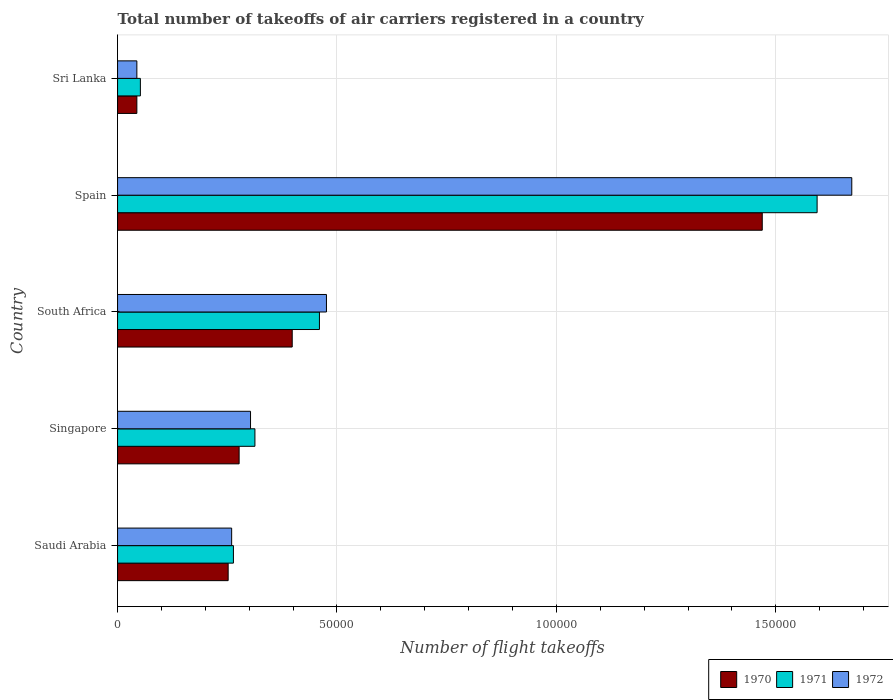How many groups of bars are there?
Offer a very short reply. 5. Are the number of bars per tick equal to the number of legend labels?
Offer a very short reply. Yes. What is the label of the 5th group of bars from the top?
Provide a short and direct response. Saudi Arabia. What is the total number of flight takeoffs in 1972 in Spain?
Your answer should be compact. 1.67e+05. Across all countries, what is the maximum total number of flight takeoffs in 1970?
Provide a succinct answer. 1.47e+05. Across all countries, what is the minimum total number of flight takeoffs in 1970?
Provide a succinct answer. 4400. In which country was the total number of flight takeoffs in 1972 maximum?
Provide a short and direct response. Spain. In which country was the total number of flight takeoffs in 1972 minimum?
Provide a short and direct response. Sri Lanka. What is the total total number of flight takeoffs in 1970 in the graph?
Offer a terse response. 2.44e+05. What is the difference between the total number of flight takeoffs in 1970 in Saudi Arabia and that in Sri Lanka?
Offer a terse response. 2.08e+04. What is the difference between the total number of flight takeoffs in 1971 in South Africa and the total number of flight takeoffs in 1972 in Singapore?
Offer a very short reply. 1.57e+04. What is the average total number of flight takeoffs in 1972 per country?
Ensure brevity in your answer.  5.51e+04. What is the difference between the total number of flight takeoffs in 1972 and total number of flight takeoffs in 1970 in Singapore?
Make the answer very short. 2600. In how many countries, is the total number of flight takeoffs in 1971 greater than 10000 ?
Ensure brevity in your answer.  4. What is the ratio of the total number of flight takeoffs in 1970 in South Africa to that in Spain?
Keep it short and to the point. 0.27. What is the difference between the highest and the second highest total number of flight takeoffs in 1971?
Make the answer very short. 1.13e+05. What is the difference between the highest and the lowest total number of flight takeoffs in 1970?
Provide a succinct answer. 1.42e+05. Is the sum of the total number of flight takeoffs in 1970 in Spain and Sri Lanka greater than the maximum total number of flight takeoffs in 1971 across all countries?
Provide a short and direct response. No. What does the 2nd bar from the bottom in Spain represents?
Offer a very short reply. 1971. How many countries are there in the graph?
Make the answer very short. 5. What is the difference between two consecutive major ticks on the X-axis?
Ensure brevity in your answer.  5.00e+04. Are the values on the major ticks of X-axis written in scientific E-notation?
Your answer should be compact. No. Where does the legend appear in the graph?
Offer a terse response. Bottom right. How many legend labels are there?
Give a very brief answer. 3. What is the title of the graph?
Provide a succinct answer. Total number of takeoffs of air carriers registered in a country. What is the label or title of the X-axis?
Ensure brevity in your answer.  Number of flight takeoffs. What is the label or title of the Y-axis?
Provide a succinct answer. Country. What is the Number of flight takeoffs in 1970 in Saudi Arabia?
Provide a succinct answer. 2.52e+04. What is the Number of flight takeoffs in 1971 in Saudi Arabia?
Offer a very short reply. 2.64e+04. What is the Number of flight takeoffs of 1972 in Saudi Arabia?
Provide a succinct answer. 2.60e+04. What is the Number of flight takeoffs of 1970 in Singapore?
Ensure brevity in your answer.  2.77e+04. What is the Number of flight takeoffs in 1971 in Singapore?
Provide a short and direct response. 3.13e+04. What is the Number of flight takeoffs in 1972 in Singapore?
Your answer should be very brief. 3.03e+04. What is the Number of flight takeoffs of 1970 in South Africa?
Offer a terse response. 3.98e+04. What is the Number of flight takeoffs in 1971 in South Africa?
Ensure brevity in your answer.  4.60e+04. What is the Number of flight takeoffs of 1972 in South Africa?
Your response must be concise. 4.76e+04. What is the Number of flight takeoffs of 1970 in Spain?
Your answer should be compact. 1.47e+05. What is the Number of flight takeoffs in 1971 in Spain?
Your answer should be compact. 1.59e+05. What is the Number of flight takeoffs in 1972 in Spain?
Your answer should be very brief. 1.67e+05. What is the Number of flight takeoffs in 1970 in Sri Lanka?
Offer a very short reply. 4400. What is the Number of flight takeoffs of 1971 in Sri Lanka?
Provide a succinct answer. 5200. What is the Number of flight takeoffs of 1972 in Sri Lanka?
Provide a succinct answer. 4400. Across all countries, what is the maximum Number of flight takeoffs in 1970?
Your answer should be compact. 1.47e+05. Across all countries, what is the maximum Number of flight takeoffs of 1971?
Provide a succinct answer. 1.59e+05. Across all countries, what is the maximum Number of flight takeoffs in 1972?
Offer a very short reply. 1.67e+05. Across all countries, what is the minimum Number of flight takeoffs in 1970?
Ensure brevity in your answer.  4400. Across all countries, what is the minimum Number of flight takeoffs of 1971?
Keep it short and to the point. 5200. Across all countries, what is the minimum Number of flight takeoffs of 1972?
Your answer should be very brief. 4400. What is the total Number of flight takeoffs of 1970 in the graph?
Ensure brevity in your answer.  2.44e+05. What is the total Number of flight takeoffs in 1971 in the graph?
Provide a succinct answer. 2.68e+05. What is the total Number of flight takeoffs of 1972 in the graph?
Offer a terse response. 2.76e+05. What is the difference between the Number of flight takeoffs in 1970 in Saudi Arabia and that in Singapore?
Ensure brevity in your answer.  -2500. What is the difference between the Number of flight takeoffs in 1971 in Saudi Arabia and that in Singapore?
Make the answer very short. -4900. What is the difference between the Number of flight takeoffs of 1972 in Saudi Arabia and that in Singapore?
Offer a very short reply. -4300. What is the difference between the Number of flight takeoffs in 1970 in Saudi Arabia and that in South Africa?
Give a very brief answer. -1.46e+04. What is the difference between the Number of flight takeoffs in 1971 in Saudi Arabia and that in South Africa?
Your response must be concise. -1.96e+04. What is the difference between the Number of flight takeoffs in 1972 in Saudi Arabia and that in South Africa?
Provide a succinct answer. -2.16e+04. What is the difference between the Number of flight takeoffs in 1970 in Saudi Arabia and that in Spain?
Offer a very short reply. -1.22e+05. What is the difference between the Number of flight takeoffs of 1971 in Saudi Arabia and that in Spain?
Your response must be concise. -1.33e+05. What is the difference between the Number of flight takeoffs in 1972 in Saudi Arabia and that in Spain?
Keep it short and to the point. -1.41e+05. What is the difference between the Number of flight takeoffs in 1970 in Saudi Arabia and that in Sri Lanka?
Your answer should be compact. 2.08e+04. What is the difference between the Number of flight takeoffs in 1971 in Saudi Arabia and that in Sri Lanka?
Offer a terse response. 2.12e+04. What is the difference between the Number of flight takeoffs in 1972 in Saudi Arabia and that in Sri Lanka?
Your answer should be very brief. 2.16e+04. What is the difference between the Number of flight takeoffs of 1970 in Singapore and that in South Africa?
Give a very brief answer. -1.21e+04. What is the difference between the Number of flight takeoffs of 1971 in Singapore and that in South Africa?
Make the answer very short. -1.47e+04. What is the difference between the Number of flight takeoffs of 1972 in Singapore and that in South Africa?
Give a very brief answer. -1.73e+04. What is the difference between the Number of flight takeoffs in 1970 in Singapore and that in Spain?
Give a very brief answer. -1.19e+05. What is the difference between the Number of flight takeoffs in 1971 in Singapore and that in Spain?
Your answer should be very brief. -1.28e+05. What is the difference between the Number of flight takeoffs of 1972 in Singapore and that in Spain?
Make the answer very short. -1.37e+05. What is the difference between the Number of flight takeoffs of 1970 in Singapore and that in Sri Lanka?
Make the answer very short. 2.33e+04. What is the difference between the Number of flight takeoffs of 1971 in Singapore and that in Sri Lanka?
Your answer should be compact. 2.61e+04. What is the difference between the Number of flight takeoffs in 1972 in Singapore and that in Sri Lanka?
Ensure brevity in your answer.  2.59e+04. What is the difference between the Number of flight takeoffs in 1970 in South Africa and that in Spain?
Keep it short and to the point. -1.07e+05. What is the difference between the Number of flight takeoffs of 1971 in South Africa and that in Spain?
Offer a terse response. -1.13e+05. What is the difference between the Number of flight takeoffs in 1972 in South Africa and that in Spain?
Offer a terse response. -1.20e+05. What is the difference between the Number of flight takeoffs in 1970 in South Africa and that in Sri Lanka?
Your answer should be compact. 3.54e+04. What is the difference between the Number of flight takeoffs in 1971 in South Africa and that in Sri Lanka?
Keep it short and to the point. 4.08e+04. What is the difference between the Number of flight takeoffs of 1972 in South Africa and that in Sri Lanka?
Your response must be concise. 4.32e+04. What is the difference between the Number of flight takeoffs of 1970 in Spain and that in Sri Lanka?
Provide a short and direct response. 1.42e+05. What is the difference between the Number of flight takeoffs in 1971 in Spain and that in Sri Lanka?
Keep it short and to the point. 1.54e+05. What is the difference between the Number of flight takeoffs of 1972 in Spain and that in Sri Lanka?
Offer a very short reply. 1.63e+05. What is the difference between the Number of flight takeoffs in 1970 in Saudi Arabia and the Number of flight takeoffs in 1971 in Singapore?
Offer a terse response. -6100. What is the difference between the Number of flight takeoffs in 1970 in Saudi Arabia and the Number of flight takeoffs in 1972 in Singapore?
Your answer should be very brief. -5100. What is the difference between the Number of flight takeoffs in 1971 in Saudi Arabia and the Number of flight takeoffs in 1972 in Singapore?
Make the answer very short. -3900. What is the difference between the Number of flight takeoffs of 1970 in Saudi Arabia and the Number of flight takeoffs of 1971 in South Africa?
Offer a very short reply. -2.08e+04. What is the difference between the Number of flight takeoffs of 1970 in Saudi Arabia and the Number of flight takeoffs of 1972 in South Africa?
Your response must be concise. -2.24e+04. What is the difference between the Number of flight takeoffs in 1971 in Saudi Arabia and the Number of flight takeoffs in 1972 in South Africa?
Your answer should be very brief. -2.12e+04. What is the difference between the Number of flight takeoffs in 1970 in Saudi Arabia and the Number of flight takeoffs in 1971 in Spain?
Your answer should be compact. -1.34e+05. What is the difference between the Number of flight takeoffs in 1970 in Saudi Arabia and the Number of flight takeoffs in 1972 in Spain?
Provide a succinct answer. -1.42e+05. What is the difference between the Number of flight takeoffs of 1971 in Saudi Arabia and the Number of flight takeoffs of 1972 in Spain?
Offer a terse response. -1.41e+05. What is the difference between the Number of flight takeoffs in 1970 in Saudi Arabia and the Number of flight takeoffs in 1972 in Sri Lanka?
Provide a short and direct response. 2.08e+04. What is the difference between the Number of flight takeoffs of 1971 in Saudi Arabia and the Number of flight takeoffs of 1972 in Sri Lanka?
Offer a very short reply. 2.20e+04. What is the difference between the Number of flight takeoffs in 1970 in Singapore and the Number of flight takeoffs in 1971 in South Africa?
Make the answer very short. -1.83e+04. What is the difference between the Number of flight takeoffs in 1970 in Singapore and the Number of flight takeoffs in 1972 in South Africa?
Provide a short and direct response. -1.99e+04. What is the difference between the Number of flight takeoffs of 1971 in Singapore and the Number of flight takeoffs of 1972 in South Africa?
Offer a terse response. -1.63e+04. What is the difference between the Number of flight takeoffs in 1970 in Singapore and the Number of flight takeoffs in 1971 in Spain?
Offer a terse response. -1.32e+05. What is the difference between the Number of flight takeoffs of 1970 in Singapore and the Number of flight takeoffs of 1972 in Spain?
Offer a terse response. -1.40e+05. What is the difference between the Number of flight takeoffs in 1971 in Singapore and the Number of flight takeoffs in 1972 in Spain?
Your answer should be very brief. -1.36e+05. What is the difference between the Number of flight takeoffs in 1970 in Singapore and the Number of flight takeoffs in 1971 in Sri Lanka?
Offer a very short reply. 2.25e+04. What is the difference between the Number of flight takeoffs of 1970 in Singapore and the Number of flight takeoffs of 1972 in Sri Lanka?
Provide a short and direct response. 2.33e+04. What is the difference between the Number of flight takeoffs of 1971 in Singapore and the Number of flight takeoffs of 1972 in Sri Lanka?
Offer a terse response. 2.69e+04. What is the difference between the Number of flight takeoffs of 1970 in South Africa and the Number of flight takeoffs of 1971 in Spain?
Your response must be concise. -1.20e+05. What is the difference between the Number of flight takeoffs of 1970 in South Africa and the Number of flight takeoffs of 1972 in Spain?
Your answer should be compact. -1.28e+05. What is the difference between the Number of flight takeoffs of 1971 in South Africa and the Number of flight takeoffs of 1972 in Spain?
Offer a very short reply. -1.21e+05. What is the difference between the Number of flight takeoffs of 1970 in South Africa and the Number of flight takeoffs of 1971 in Sri Lanka?
Your answer should be very brief. 3.46e+04. What is the difference between the Number of flight takeoffs in 1970 in South Africa and the Number of flight takeoffs in 1972 in Sri Lanka?
Give a very brief answer. 3.54e+04. What is the difference between the Number of flight takeoffs in 1971 in South Africa and the Number of flight takeoffs in 1972 in Sri Lanka?
Offer a terse response. 4.16e+04. What is the difference between the Number of flight takeoffs of 1970 in Spain and the Number of flight takeoffs of 1971 in Sri Lanka?
Your answer should be compact. 1.42e+05. What is the difference between the Number of flight takeoffs in 1970 in Spain and the Number of flight takeoffs in 1972 in Sri Lanka?
Offer a very short reply. 1.42e+05. What is the difference between the Number of flight takeoffs of 1971 in Spain and the Number of flight takeoffs of 1972 in Sri Lanka?
Make the answer very short. 1.55e+05. What is the average Number of flight takeoffs of 1970 per country?
Your answer should be compact. 4.88e+04. What is the average Number of flight takeoffs of 1971 per country?
Offer a very short reply. 5.37e+04. What is the average Number of flight takeoffs of 1972 per country?
Provide a short and direct response. 5.51e+04. What is the difference between the Number of flight takeoffs of 1970 and Number of flight takeoffs of 1971 in Saudi Arabia?
Make the answer very short. -1200. What is the difference between the Number of flight takeoffs in 1970 and Number of flight takeoffs in 1972 in Saudi Arabia?
Give a very brief answer. -800. What is the difference between the Number of flight takeoffs of 1970 and Number of flight takeoffs of 1971 in Singapore?
Your response must be concise. -3600. What is the difference between the Number of flight takeoffs of 1970 and Number of flight takeoffs of 1972 in Singapore?
Provide a short and direct response. -2600. What is the difference between the Number of flight takeoffs of 1971 and Number of flight takeoffs of 1972 in Singapore?
Your answer should be compact. 1000. What is the difference between the Number of flight takeoffs in 1970 and Number of flight takeoffs in 1971 in South Africa?
Your answer should be compact. -6200. What is the difference between the Number of flight takeoffs of 1970 and Number of flight takeoffs of 1972 in South Africa?
Offer a very short reply. -7800. What is the difference between the Number of flight takeoffs of 1971 and Number of flight takeoffs of 1972 in South Africa?
Keep it short and to the point. -1600. What is the difference between the Number of flight takeoffs of 1970 and Number of flight takeoffs of 1971 in Spain?
Give a very brief answer. -1.25e+04. What is the difference between the Number of flight takeoffs in 1970 and Number of flight takeoffs in 1972 in Spain?
Your response must be concise. -2.04e+04. What is the difference between the Number of flight takeoffs in 1971 and Number of flight takeoffs in 1972 in Spain?
Provide a succinct answer. -7900. What is the difference between the Number of flight takeoffs of 1970 and Number of flight takeoffs of 1971 in Sri Lanka?
Keep it short and to the point. -800. What is the difference between the Number of flight takeoffs in 1971 and Number of flight takeoffs in 1972 in Sri Lanka?
Ensure brevity in your answer.  800. What is the ratio of the Number of flight takeoffs in 1970 in Saudi Arabia to that in Singapore?
Make the answer very short. 0.91. What is the ratio of the Number of flight takeoffs of 1971 in Saudi Arabia to that in Singapore?
Ensure brevity in your answer.  0.84. What is the ratio of the Number of flight takeoffs of 1972 in Saudi Arabia to that in Singapore?
Provide a succinct answer. 0.86. What is the ratio of the Number of flight takeoffs in 1970 in Saudi Arabia to that in South Africa?
Ensure brevity in your answer.  0.63. What is the ratio of the Number of flight takeoffs of 1971 in Saudi Arabia to that in South Africa?
Provide a succinct answer. 0.57. What is the ratio of the Number of flight takeoffs in 1972 in Saudi Arabia to that in South Africa?
Give a very brief answer. 0.55. What is the ratio of the Number of flight takeoffs in 1970 in Saudi Arabia to that in Spain?
Offer a very short reply. 0.17. What is the ratio of the Number of flight takeoffs in 1971 in Saudi Arabia to that in Spain?
Offer a terse response. 0.17. What is the ratio of the Number of flight takeoffs of 1972 in Saudi Arabia to that in Spain?
Ensure brevity in your answer.  0.16. What is the ratio of the Number of flight takeoffs in 1970 in Saudi Arabia to that in Sri Lanka?
Offer a terse response. 5.73. What is the ratio of the Number of flight takeoffs in 1971 in Saudi Arabia to that in Sri Lanka?
Offer a very short reply. 5.08. What is the ratio of the Number of flight takeoffs of 1972 in Saudi Arabia to that in Sri Lanka?
Make the answer very short. 5.91. What is the ratio of the Number of flight takeoffs in 1970 in Singapore to that in South Africa?
Your answer should be very brief. 0.7. What is the ratio of the Number of flight takeoffs in 1971 in Singapore to that in South Africa?
Offer a very short reply. 0.68. What is the ratio of the Number of flight takeoffs of 1972 in Singapore to that in South Africa?
Provide a short and direct response. 0.64. What is the ratio of the Number of flight takeoffs in 1970 in Singapore to that in Spain?
Give a very brief answer. 0.19. What is the ratio of the Number of flight takeoffs in 1971 in Singapore to that in Spain?
Offer a terse response. 0.2. What is the ratio of the Number of flight takeoffs in 1972 in Singapore to that in Spain?
Offer a very short reply. 0.18. What is the ratio of the Number of flight takeoffs in 1970 in Singapore to that in Sri Lanka?
Keep it short and to the point. 6.3. What is the ratio of the Number of flight takeoffs in 1971 in Singapore to that in Sri Lanka?
Provide a short and direct response. 6.02. What is the ratio of the Number of flight takeoffs in 1972 in Singapore to that in Sri Lanka?
Make the answer very short. 6.89. What is the ratio of the Number of flight takeoffs of 1970 in South Africa to that in Spain?
Ensure brevity in your answer.  0.27. What is the ratio of the Number of flight takeoffs in 1971 in South Africa to that in Spain?
Keep it short and to the point. 0.29. What is the ratio of the Number of flight takeoffs of 1972 in South Africa to that in Spain?
Provide a succinct answer. 0.28. What is the ratio of the Number of flight takeoffs in 1970 in South Africa to that in Sri Lanka?
Ensure brevity in your answer.  9.05. What is the ratio of the Number of flight takeoffs in 1971 in South Africa to that in Sri Lanka?
Make the answer very short. 8.85. What is the ratio of the Number of flight takeoffs in 1972 in South Africa to that in Sri Lanka?
Ensure brevity in your answer.  10.82. What is the ratio of the Number of flight takeoffs of 1970 in Spain to that in Sri Lanka?
Your answer should be very brief. 33.39. What is the ratio of the Number of flight takeoffs of 1971 in Spain to that in Sri Lanka?
Your answer should be very brief. 30.65. What is the ratio of the Number of flight takeoffs of 1972 in Spain to that in Sri Lanka?
Provide a short and direct response. 38.02. What is the difference between the highest and the second highest Number of flight takeoffs of 1970?
Ensure brevity in your answer.  1.07e+05. What is the difference between the highest and the second highest Number of flight takeoffs in 1971?
Your answer should be very brief. 1.13e+05. What is the difference between the highest and the second highest Number of flight takeoffs in 1972?
Keep it short and to the point. 1.20e+05. What is the difference between the highest and the lowest Number of flight takeoffs of 1970?
Your answer should be compact. 1.42e+05. What is the difference between the highest and the lowest Number of flight takeoffs in 1971?
Provide a short and direct response. 1.54e+05. What is the difference between the highest and the lowest Number of flight takeoffs of 1972?
Your response must be concise. 1.63e+05. 